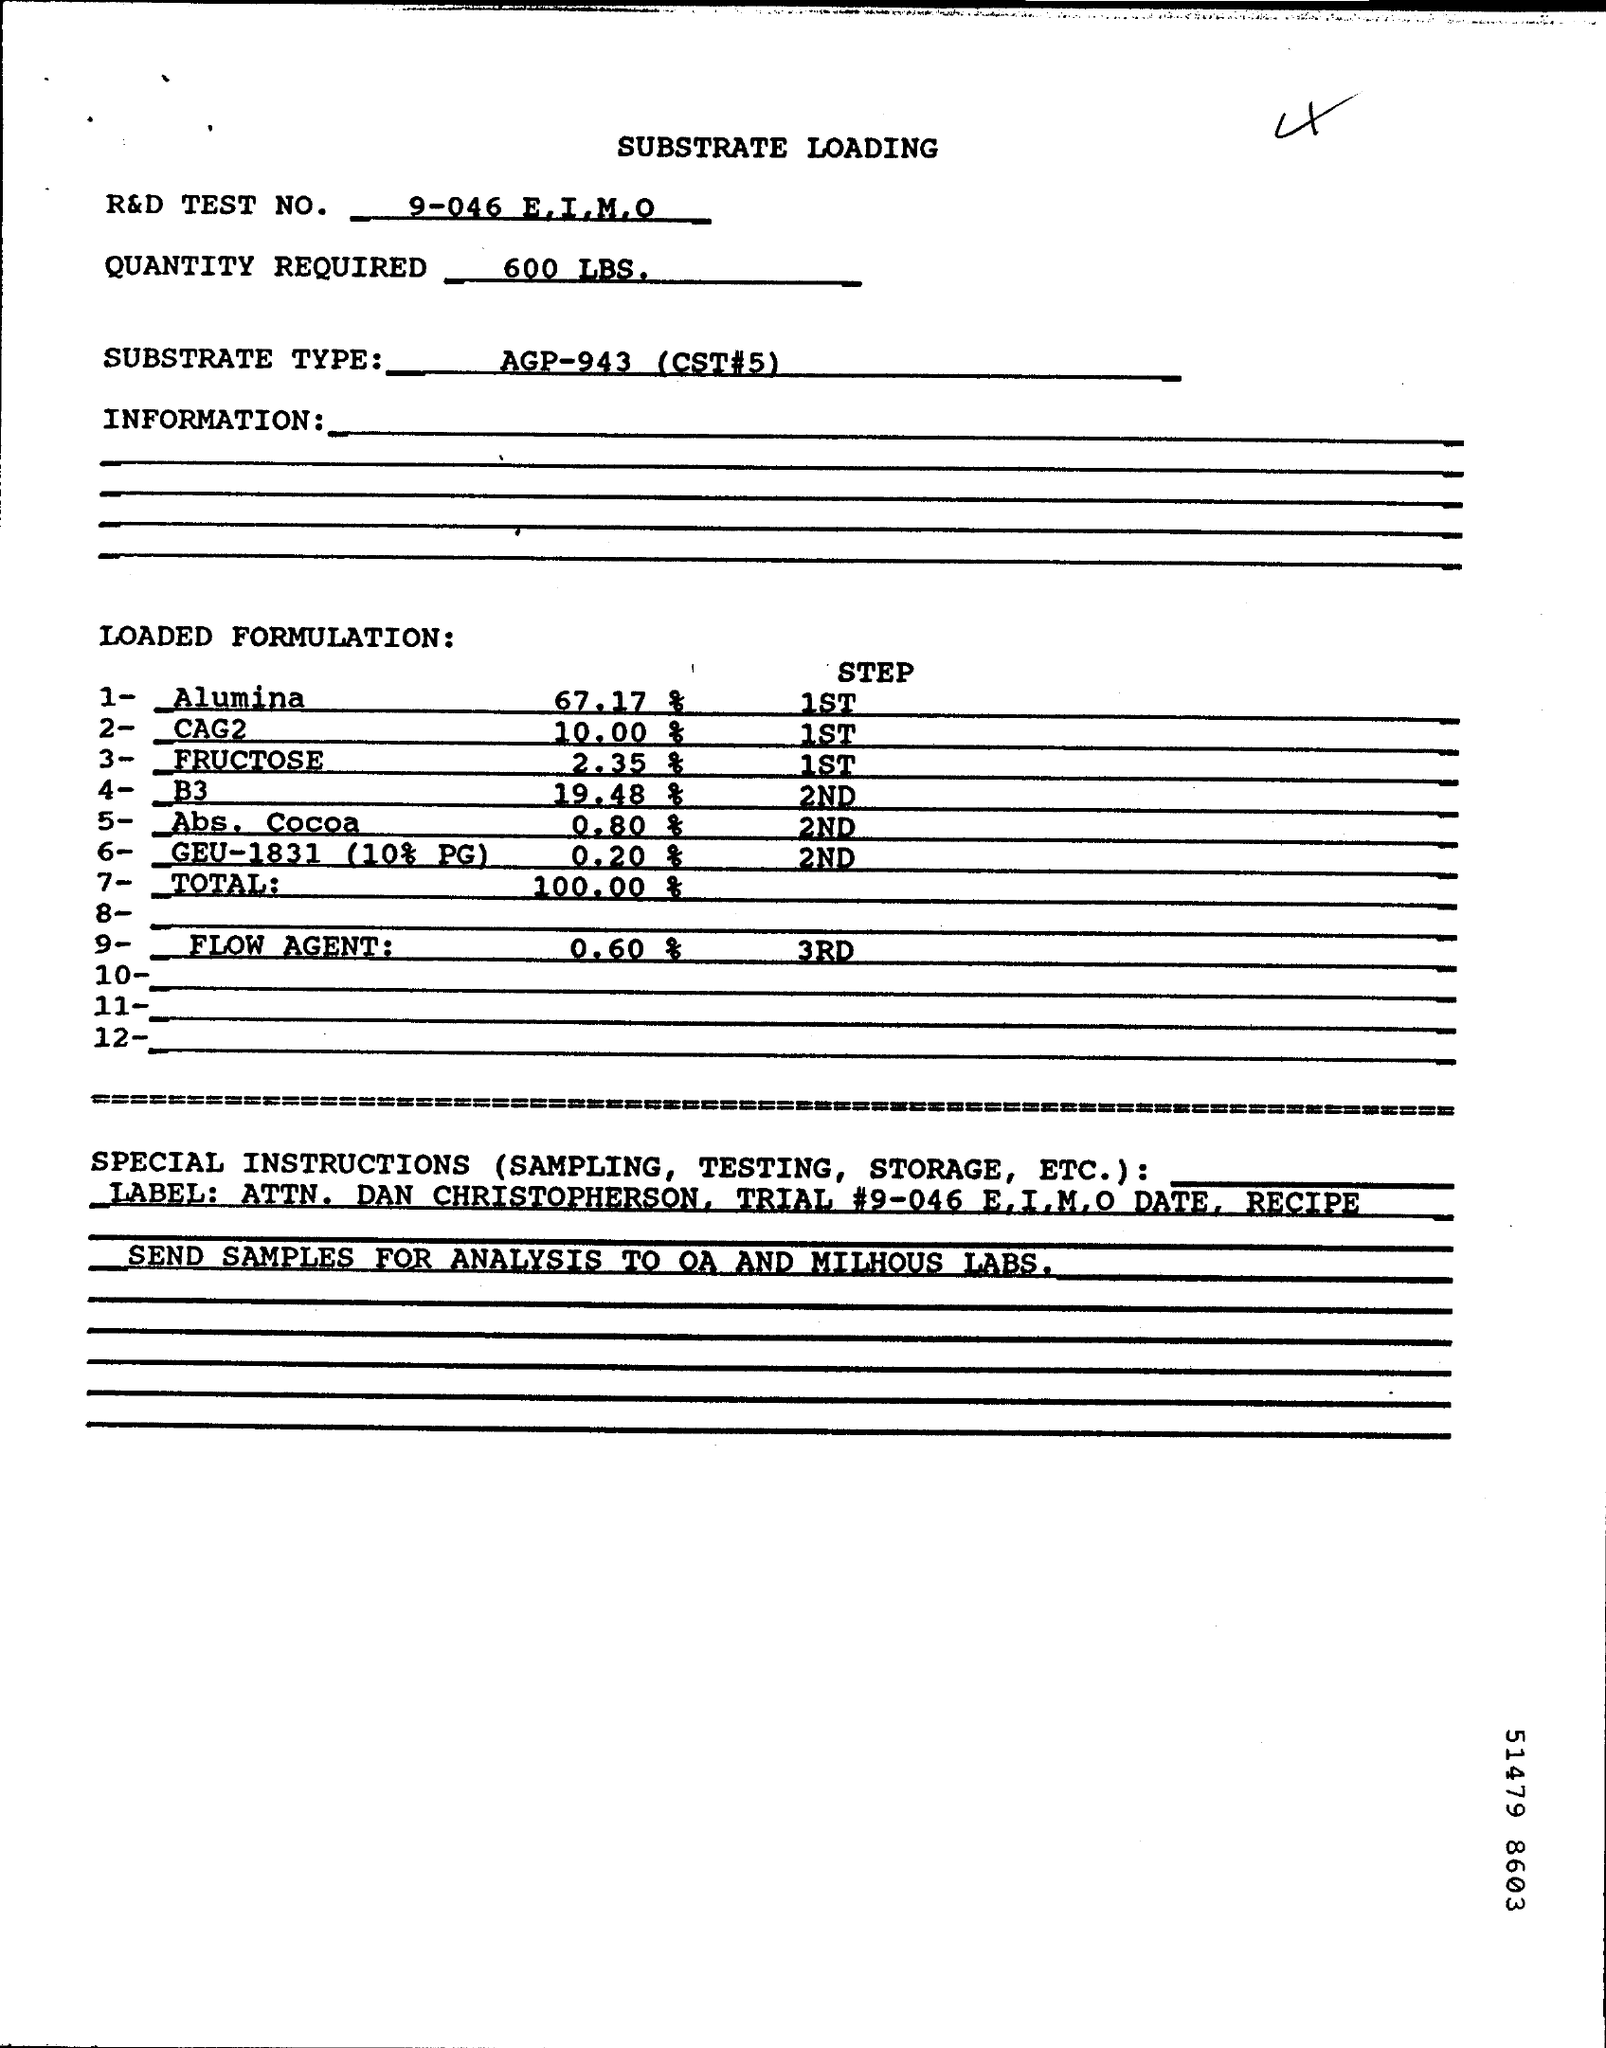How much QUANTITY REQUIRED for testing?
Keep it short and to the point. 600 LBS. 